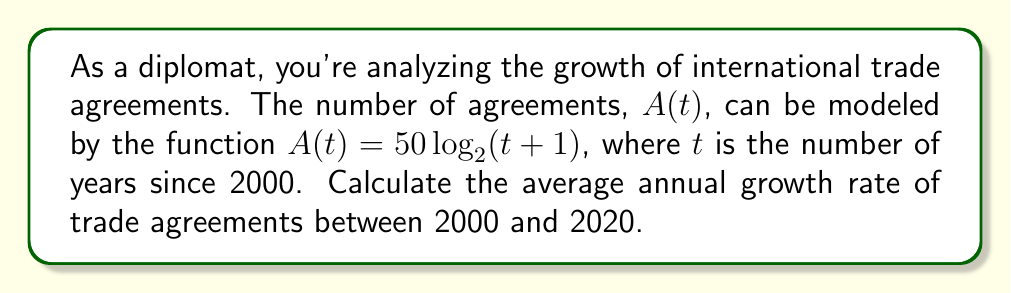Give your solution to this math problem. To solve this problem, we'll follow these steps:

1) First, let's calculate the number of agreements in 2000 and 2020:

   For 2000 (t = 0): $A(0) = 50 \log_2(0+1) = 50 \log_2(1) = 0$
   For 2020 (t = 20): $A(20) = 50 \log_2(20+1) = 50 \log_2(21) \approx 232.19$

2) The total growth over 20 years is: $232.19 - 0 = 232.19$

3) To find the average annual growth rate (r), we can use the compound interest formula:

   $A = P(1+r)^t$

   Where A is the final amount, P is the initial amount, r is the annual growth rate, and t is the number of years.

4) Substituting our values:

   $232.19 = 0(1+r)^{20}$

   However, this doesn't work because our initial value is 0. In this case, we need to use a different approach.

5) We can calculate the average absolute growth per year:

   $\frac{232.19}{20} \approx 11.61$ agreements per year

6) To express this as a growth rate, we need to consider it relative to the previous year's total. Since this changes each year, we'll use the geometric mean of the growth rates:

   $r = \sqrt[20]{\frac{232.19}{0 + \epsilon}} - 1$

   Where $\epsilon$ is a small number to avoid division by zero. Let's use 0.01.

7) Calculating:

   $r = \sqrt[20]{\frac{232.19}{0.01}} - 1 \approx 2.0178 = 201.78\%$
Answer: $201.78\%$ 